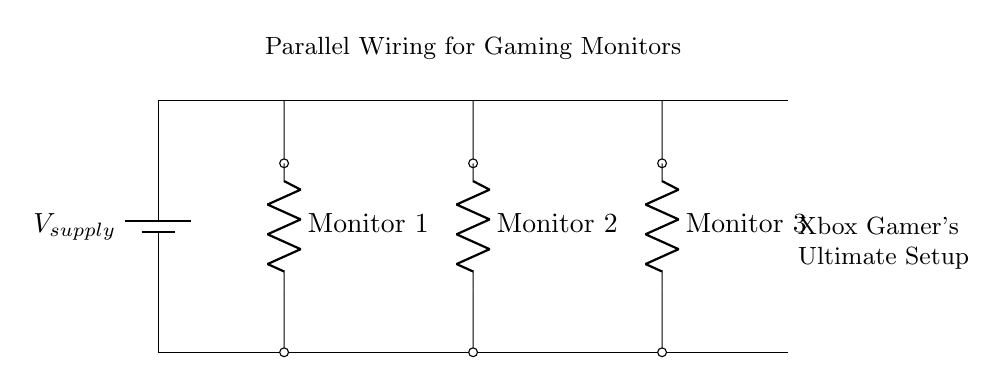What type of wiring system is shown in the diagram? The diagram clearly displays a parallel wiring system, where multiple components (monitors) are connected across the same voltage source. This is evident from the separate connections of each monitor that branch from the main power line.
Answer: Parallel How many monitors are connected in this setup? The diagram illustrates three monitors connected in parallel, as indicated by the three distinct resistive loads labeled Monitor 1, Monitor 2, and Monitor 3.
Answer: Three What is the role of the battery in this circuit? The battery acts as the power supply, providing a constant voltage to all connected monitors simultaneously. The main power line represents where the power is supplied from the battery to the monitors.
Answer: Power supply What happens to the total resistance if one monitor is disconnected? The total resistance decreases if one monitor is disconnected because the remaining monitors still provide alternative paths for current flow, typical of parallel circuits where total resistance is less than the smallest individual resistance.
Answer: Decreases What is the benefit of using a parallel wiring system for monitors in gaming? Using a parallel wiring system ensures that each monitor receives the same voltage and can operate independently; if one monitor fails or is turned off, the others continue to function without interruption, which is crucial for competitive gaming.
Answer: Independent operation 